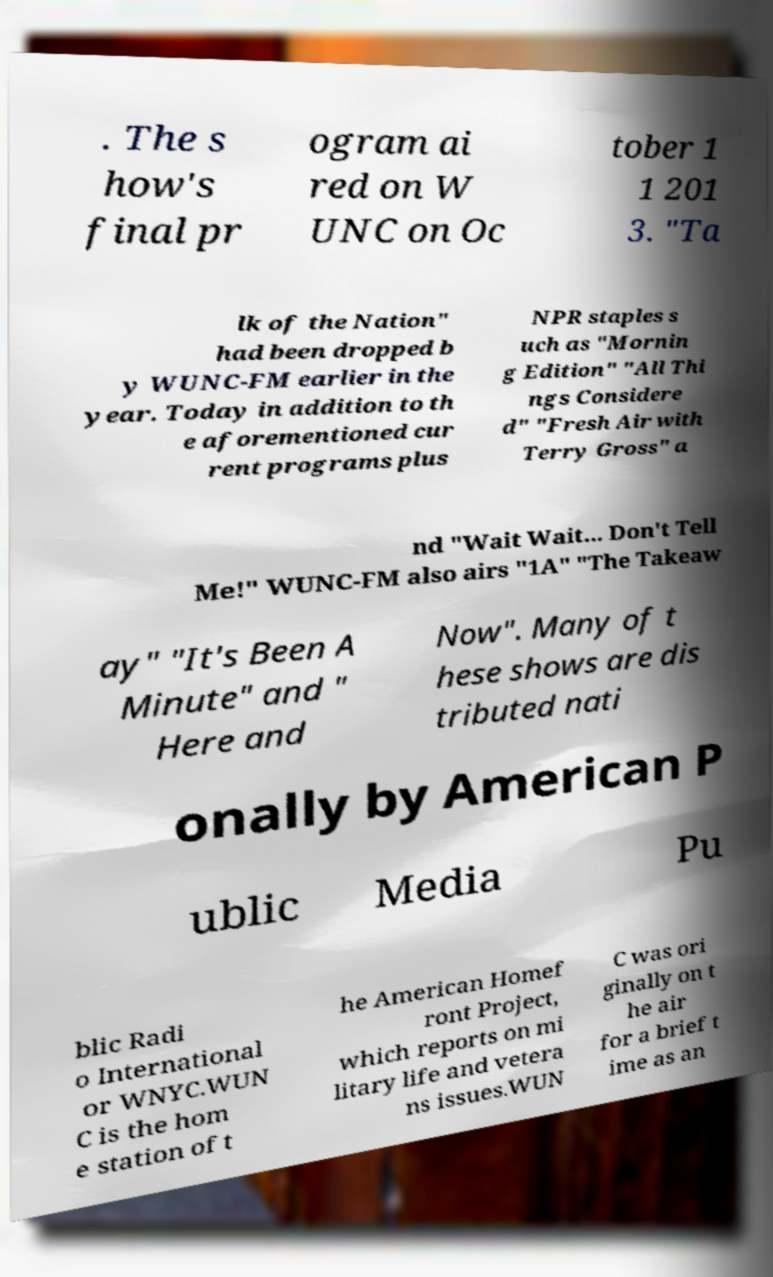What messages or text are displayed in this image? I need them in a readable, typed format. . The s how's final pr ogram ai red on W UNC on Oc tober 1 1 201 3. "Ta lk of the Nation" had been dropped b y WUNC-FM earlier in the year. Today in addition to th e aforementioned cur rent programs plus NPR staples s uch as "Mornin g Edition" "All Thi ngs Considere d" "Fresh Air with Terry Gross" a nd "Wait Wait... Don't Tell Me!" WUNC-FM also airs "1A" "The Takeaw ay" "It's Been A Minute" and " Here and Now". Many of t hese shows are dis tributed nati onally by American P ublic Media Pu blic Radi o International or WNYC.WUN C is the hom e station of t he American Homef ront Project, which reports on mi litary life and vetera ns issues.WUN C was ori ginally on t he air for a brief t ime as an 